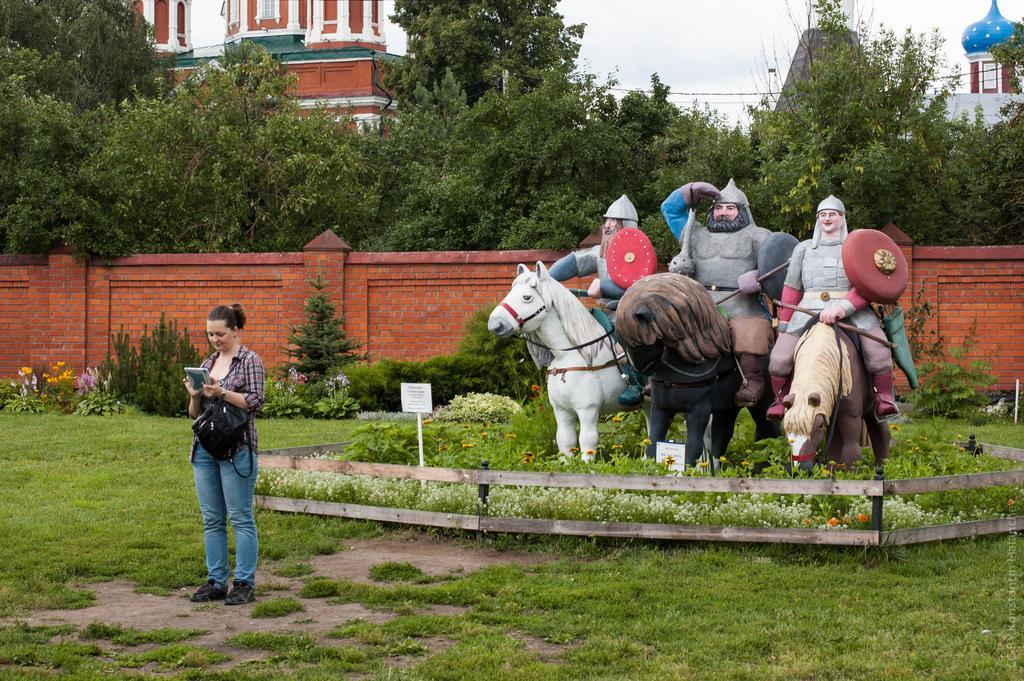How would you summarize this image in a sentence or two? In this image, we can see some statues. We can see the ground with grass. We can see some plants. Among them, we can see some plants with flowers. We can see the fence. We can see a person holding an object is standing. There are a few boards with text. We can see some trees and buildings. We can also see some wires and the sky. We can see the wall. 